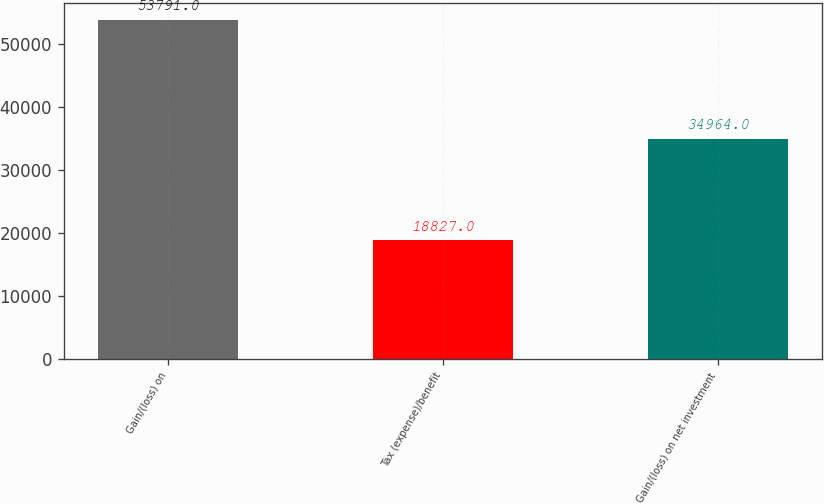Convert chart. <chart><loc_0><loc_0><loc_500><loc_500><bar_chart><fcel>Gain/(loss) on<fcel>Tax (expense)/benefit<fcel>Gain/(loss) on net investment<nl><fcel>53791<fcel>18827<fcel>34964<nl></chart> 